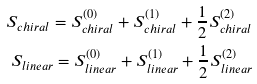Convert formula to latex. <formula><loc_0><loc_0><loc_500><loc_500>S _ { c h i r a l } = S _ { c h i r a l } ^ { ( 0 ) } + S _ { c h i r a l } ^ { ( 1 ) } + \frac { 1 } { 2 } S _ { c h i r a l } ^ { ( 2 ) } \\ S _ { l i n e a r } = S _ { l i n e a r } ^ { ( 0 ) } + S _ { l i n e a r } ^ { ( 1 ) } + \frac { 1 } { 2 } S _ { l i n e a r } ^ { ( 2 ) }</formula> 